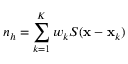<formula> <loc_0><loc_0><loc_500><loc_500>n _ { h } = \sum _ { k = 1 } ^ { K } w _ { k } S ( { \mathbf x } - { \mathbf x } _ { k } )</formula> 